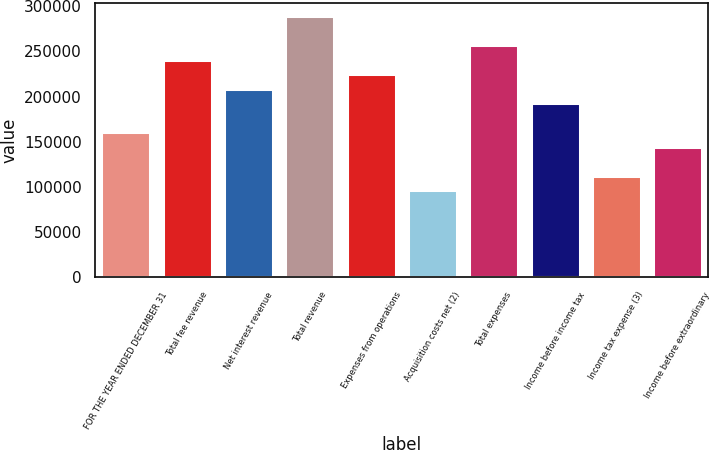Convert chart. <chart><loc_0><loc_0><loc_500><loc_500><bar_chart><fcel>FOR THE YEAR ENDED DECEMBER 31<fcel>Total fee revenue<fcel>Net interest revenue<fcel>Total revenue<fcel>Expenses from operations<fcel>Acquisition costs net (2)<fcel>Total expenses<fcel>Income before income tax<fcel>Income tax expense (3)<fcel>Income before extraordinary<nl><fcel>160505<fcel>240758<fcel>208657<fcel>288909<fcel>224707<fcel>96303<fcel>256808<fcel>192606<fcel>112354<fcel>144455<nl></chart> 